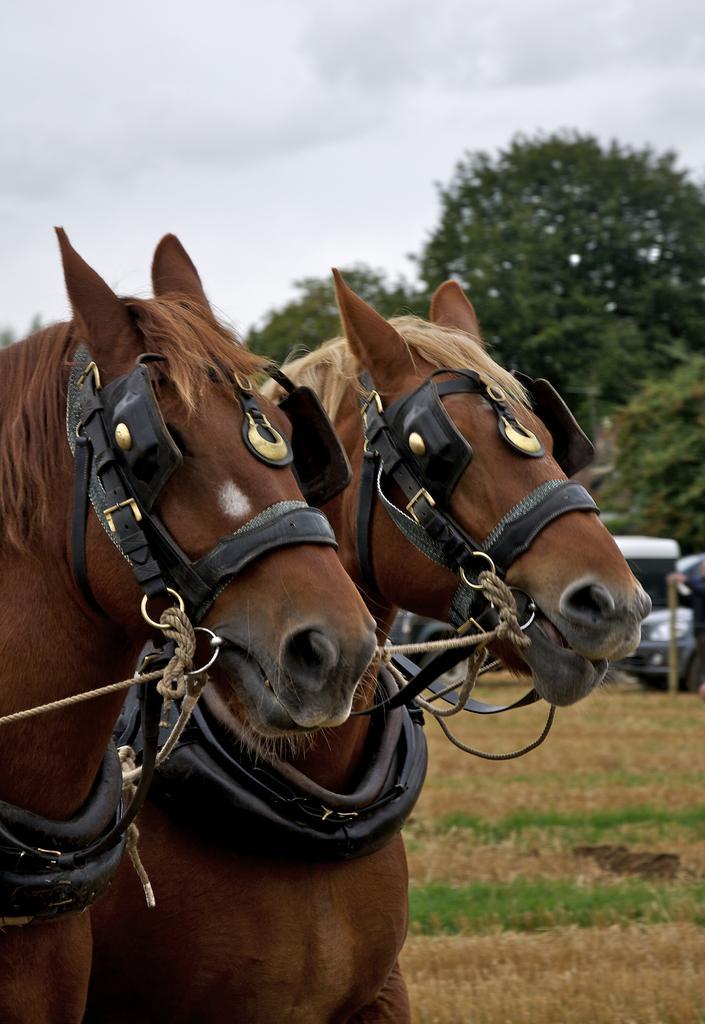Could you give a brief overview of what you see in this image? There are two horses. This is ground and there is a vehicle. In the background we can see trees and sky. 